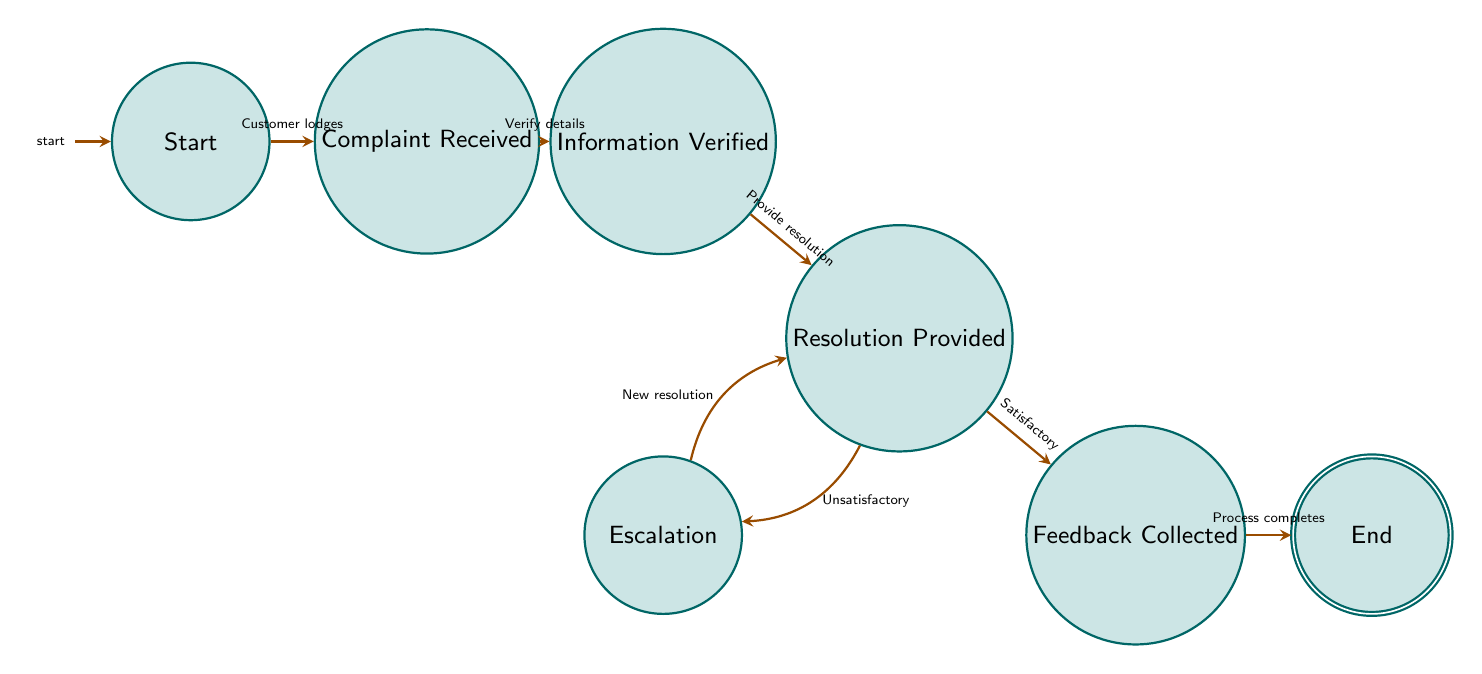What is the initial state of the complaint resolution process? The diagram indicates that the initial state is labeled "Start," which is the first point where the complaint process begins.
Answer: Start How many states are present in this finite state machine? By counting the nodes in the diagram, there are a total of seven states represented: Start, Complaint Received, Information Verified, Resolution Provided, Escalation, Feedback Collected, and End.
Answer: 7 What state follows "Information Verified"? The transition from "Information Verified" leads directly to the "Resolution Provided" state, as indicated by the accompanying arrow in the diagram.
Answer: Resolution Provided What transition occurs after a satisfactory resolution? According to the diagram, once a satisfactory resolution is provided, the flow moves to the "Feedback Collected" state, depicted by the arrow from "Resolution Provided" to "Feedback Collected."
Answer: Feedback Collected What happens if the resolution is unsatisfactory? The diagram shows that if the resolution is deemed unsatisfactory, the complaint is escalated to a higher level, moving from "Resolution Provided" to "Escalation," as illustrated by the connected arrow.
Answer: Escalation Which state signifies the completion of the complaint process? The "End" state is clearly identified in the diagram as the final state, indicating that the complaint process has been completed successfully after collecting feedback.
Answer: End How many transitions are there in the finite state machine? By examining the diagram, there are a total of six transitions connecting the states: Customer lodges, Verify details, Provide resolution, New resolution, Satisfactory, and Process completes.
Answer: 6 What is the role of the "Escalation" state? The "Escalation" state serves the purpose of allowing complaints to be reviewed at a higher level when the initial resolution provided is unsatisfactory, as shown by the transition from the "Resolution Provided" state.
Answer: Review at higher level 